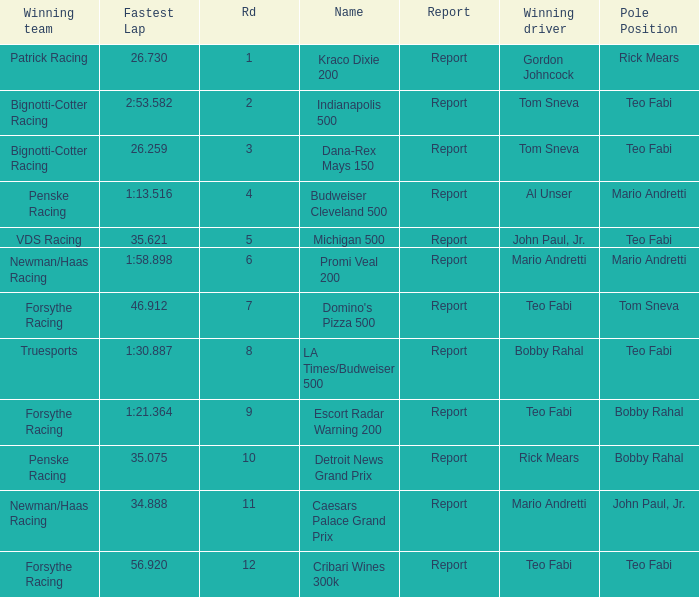What is the highest Rd that Tom Sneva had the pole position in? 7.0. 